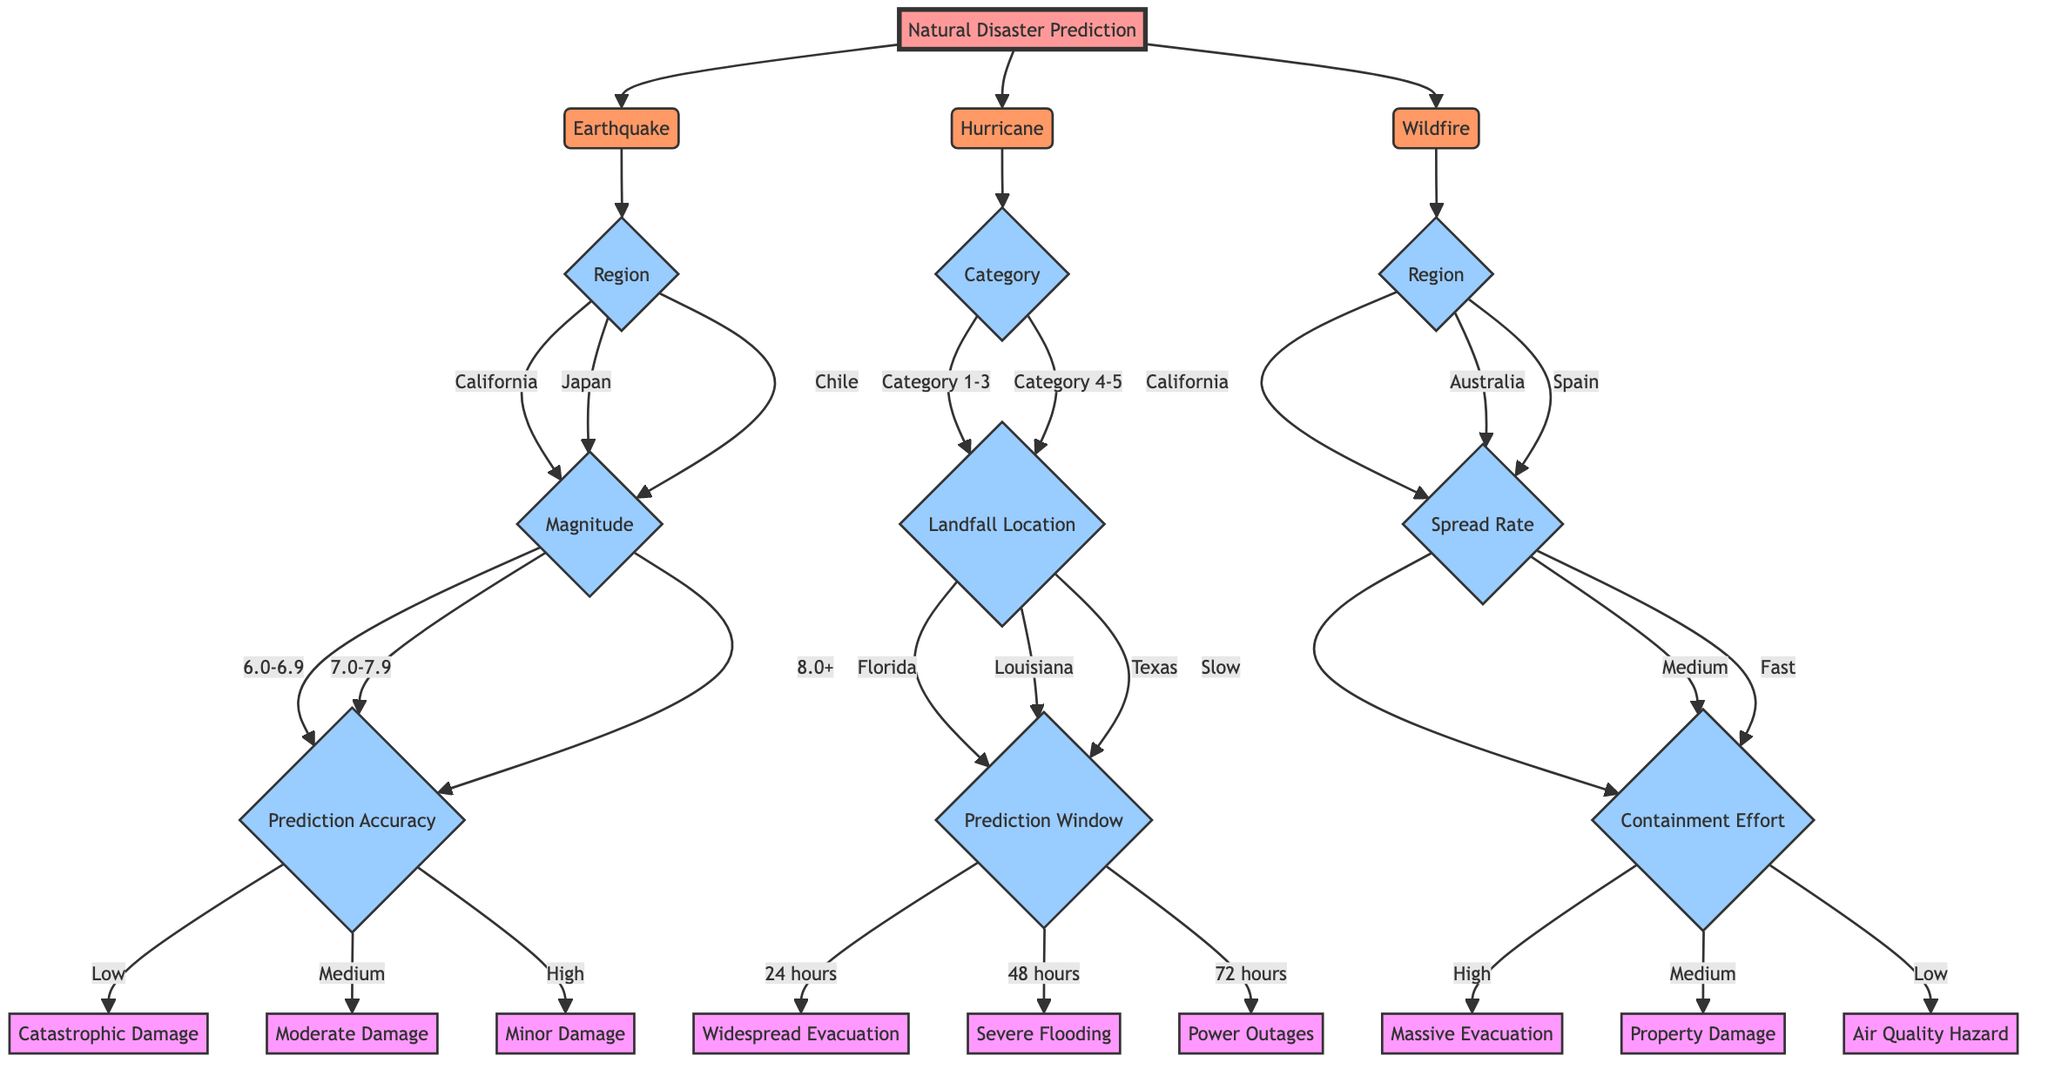What's the first natural disaster type in the diagram? The diagram starts with the node labeled "Natural Disaster Prediction," which branches out to "Earthquake," "Hurricane," and "Wildfire." The first listed is "Earthquake."
Answer: Earthquake How many regions are listed under Earthquake? The Earthquake node branches into three regions: California, Japan, and Chile. Counting these gives a total of three regions.
Answer: 3 What is the possible outcome if the prediction accuracy is high for an earthquake of magnitude 7.0-7.9? If the magnitude is 7.0-7.9 and the prediction accuracy is high, the outcome is "Minor Damage," which is directly shown in the outcome nodes stemming from that path.
Answer: Minor Damage Which disaster has the highest category listed in the diagram? The Hurricane node includes various categories from 1 to 5, with Category 5 being the highest. This is confirmed by tracing down the branches of the Hurricane node.
Answer: Category 5 In which region would a wildfire be considered a severe hazard if the spread rate is fast and the containment effort is low? For a wildfire, if the region is California, Australia, or Spain, with a fast spread rate and low containment effort, the outcome is "Air Quality Hazard." This is reasoned by evaluating the outcomes for the fast spread and low containment.
Answer: Air Quality Hazard If a hurricane has a prediction window of 48 hours and makes landfall in Louisiana, what is the expected outcome? For the Hurricane node with a landfall in Louisiana and a prediction window of 48 hours, the outcome is "Severe Flooding." This is derived from following the branches for that specific landfall and time frame.
Answer: Severe Flooding Which natural disaster has the outcome labeled as "False Alarm"? Both Earthquake and Hurricane nodes include "False Alarm" as one of their possible outcomes, but in the context of wildfires, "False Alarm" is not listed. Therefore, both of the first two types include it.
Answer: Earthquake, Hurricane What is the spread rate associated with massive evacuation in a wildfire situation? A massive evacuation during a wildfire situation is linked to a high containment effort and can also relate to the spread rate. Looking at the paths, the spread rate must be classified as either slow, medium, or fast. The specific answer is found within the medium to high ranges, which could yield "High."
Answer: High What prediction accuracy is linked to catastrophic damage from an earthquake? A catastrophic damage outcome is linked to a low prediction accuracy for earthquakes with a magnitude of 6.0-6.9 according to the respective branches leading to that specific outcome.
Answer: Low 